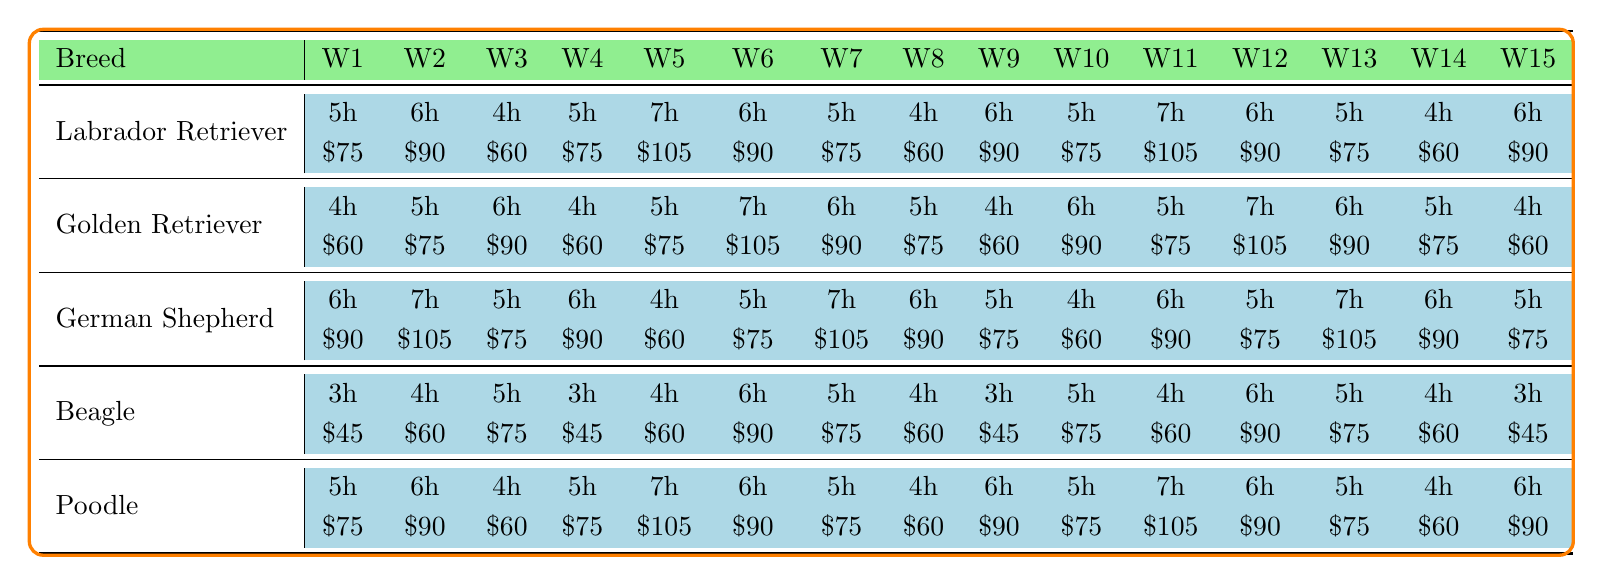What breed had the highest earnings in Week 5? In Week 5, the Labrador Retriever, Golden Retriever, German Shepherd, and Poodle each earned $105, which is the highest amount for that week.
Answer: Labrador Retriever, Golden Retriever, German Shepherd, Poodle Which breed consistently had the lowest earnings throughout the 15 weeks? The Beagle breed consistently had the lowest earnings, with values of $45, $60, and $75 throughout the 15 weeks. In comparison, other breeds typically earned more than these amounts.
Answer: Beagle What is the total number of hours worked by the Chihuahua across all weeks? The table doesn't include data for the Chihuahua, which means the total hours worked are considered zero as there are no logged hours provided for this breed.
Answer: 0 How much did the Golden Retriever earn in Week 6, and how does it compare to Week 1? In Week 6, the Golden Retriever earned $105. In Week 1, it earned $60. The comparison shows an increase of $45 from Week 1 to Week 6.
Answer: $105; increased by $45 What is the average hours worked per week by the Labrador Retriever? Summing the hours worked by the Labrador Retriever over 15 weeks results in 5 + 6 + 4 + 5 + 7 + 6 + 5 + 4 + 6 + 5 + 7 + 6 + 5 + 4 + 6 =  90 hours. Dividing this by 15 gives an average of 6 hours per week.
Answer: 6 hours Did the German Shepherd ever earn less than $60 in any week? The German Shepherd earned $60 in Week 5 and $60 in Week 10 but did not earn less than $60 during any week. The earnings were either $60 or higher throughout the weeks analyzed.
Answer: No What is the difference in average earnings between the Labrador Retriever and the Poodle for the semester? The average earnings for the Labrador Retriever is calculated by summing its earnings and dividing by 15, resulting in ($75 + $90 + $60 + $75 + $105 + $90 + $75 + $60 + $90 + $75 + $105 + $90 + $75 + $60 + $90) / 15 = $81. The Poodle's average earnings are calculated similarly, totaling $81. The difference is $81 - $81 = $0.
Answer: $0 How many hours did the Beagle work in total over the semester? By adding the hours for the Beagle across all weeks: 3 + 4 + 5 + 3 + 4 + 6 + 5 + 4 + 3 + 5 + 4 + 6 + 5 + 4 + 3 = 56 hours total.
Answer: 56 hours Which breed had the most week-to-week earnings fluctuations, and what was the highest difference observed? The breed with the highest fluctuations in earnings was the German Shepherd. Observing the earnings reveals the largest increase in earnings between Week 2 ($105) and Week 5 ($60), which is a fluctuation of $45.
Answer: German Shepherd; $45 Was there ever a week when the earnings for any breed were exactly $90? Yes, multiple breeds had earnings of $90 in several weeks. Notably, the Labrador Retriever, Golden Retriever, German Shepherd, and Poodle all had weeks with $90 earnings.
Answer: Yes 